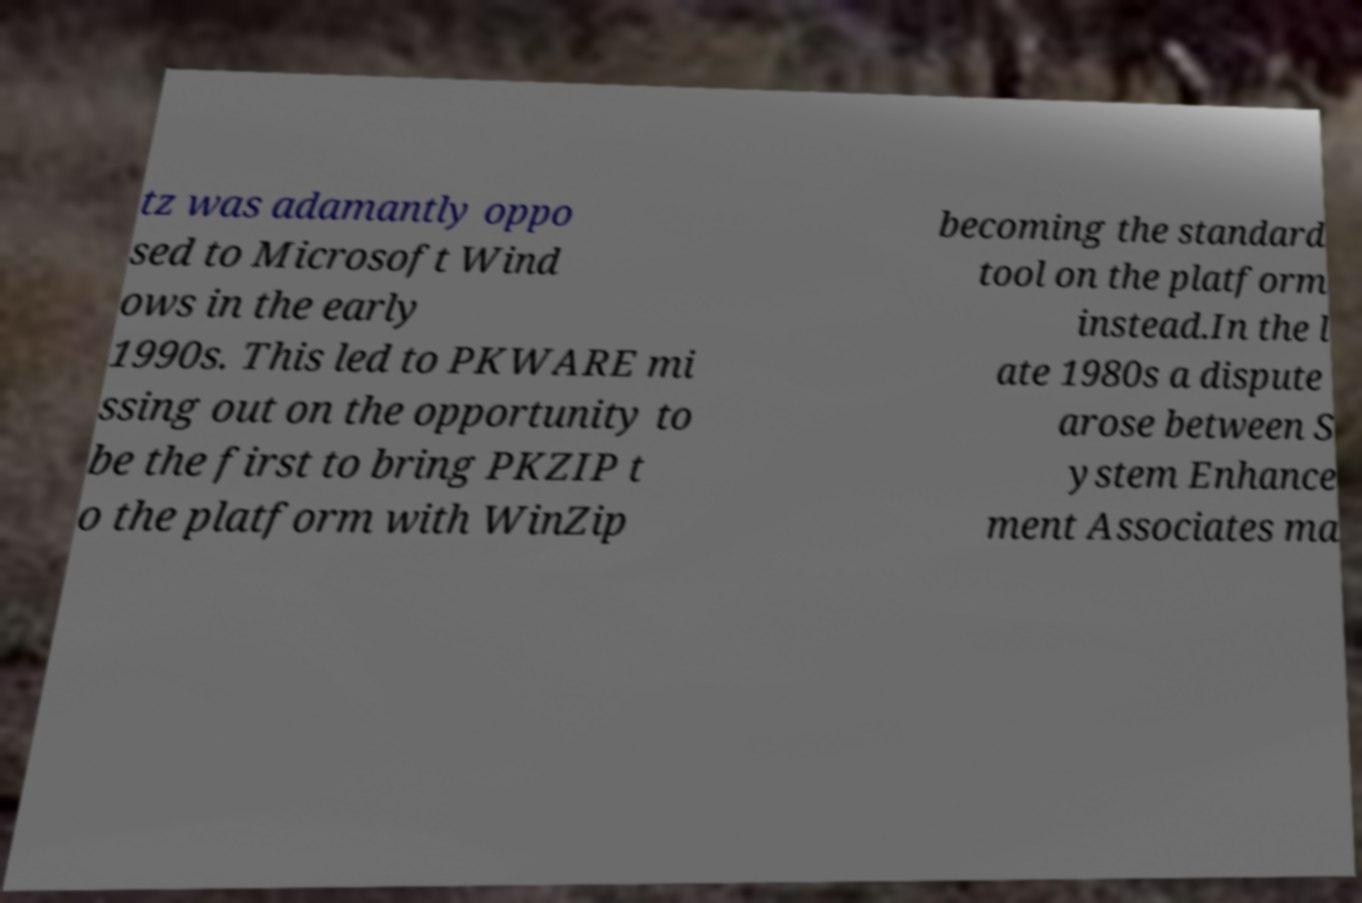What messages or text are displayed in this image? I need them in a readable, typed format. tz was adamantly oppo sed to Microsoft Wind ows in the early 1990s. This led to PKWARE mi ssing out on the opportunity to be the first to bring PKZIP t o the platform with WinZip becoming the standard tool on the platform instead.In the l ate 1980s a dispute arose between S ystem Enhance ment Associates ma 